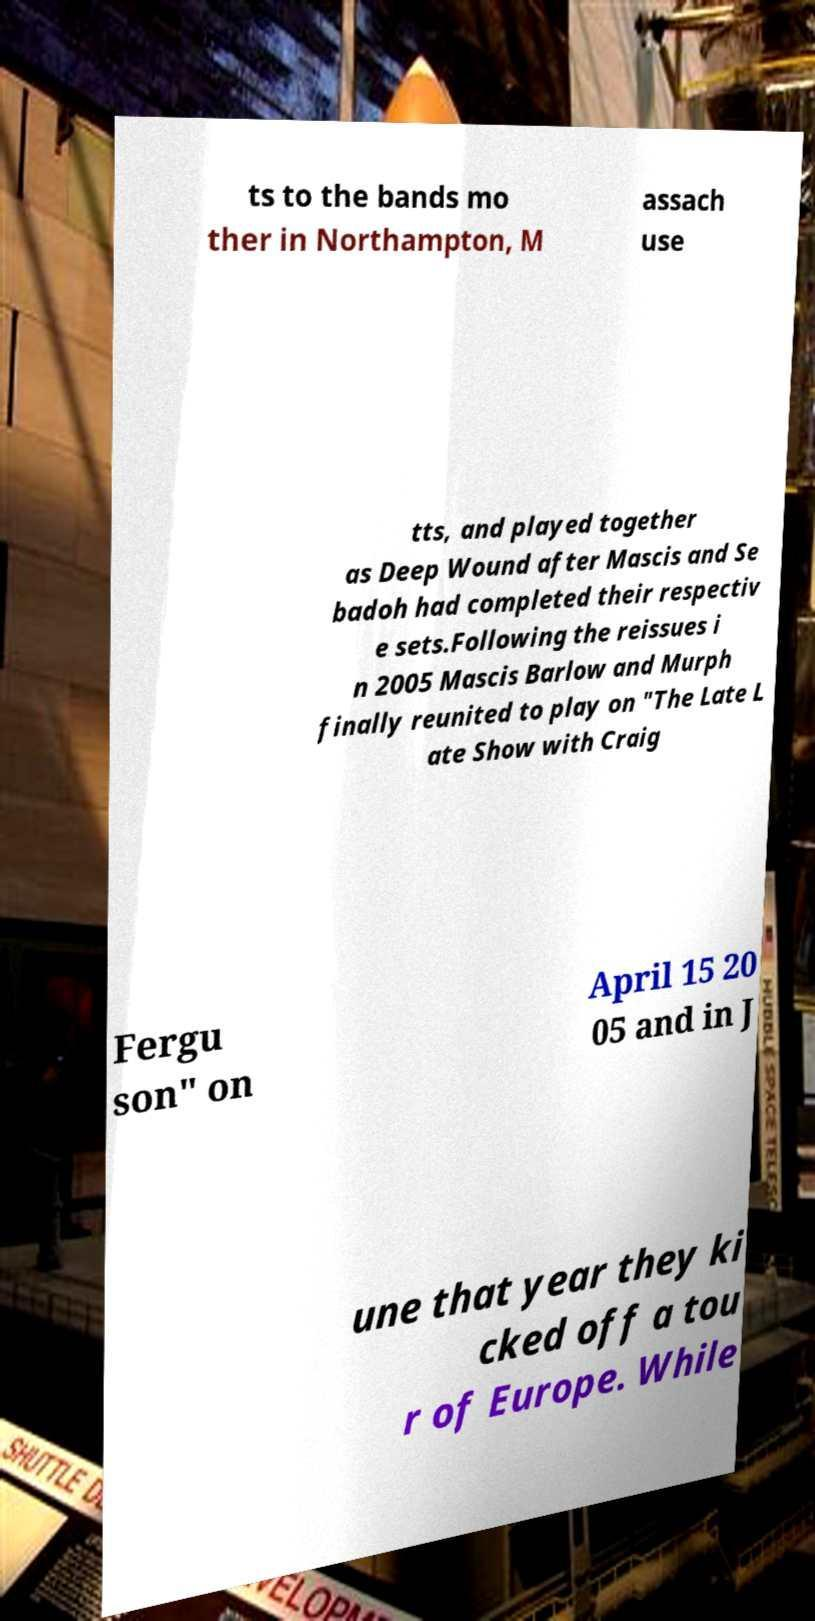What messages or text are displayed in this image? I need them in a readable, typed format. ts to the bands mo ther in Northampton, M assach use tts, and played together as Deep Wound after Mascis and Se badoh had completed their respectiv e sets.Following the reissues i n 2005 Mascis Barlow and Murph finally reunited to play on "The Late L ate Show with Craig Fergu son" on April 15 20 05 and in J une that year they ki cked off a tou r of Europe. While 